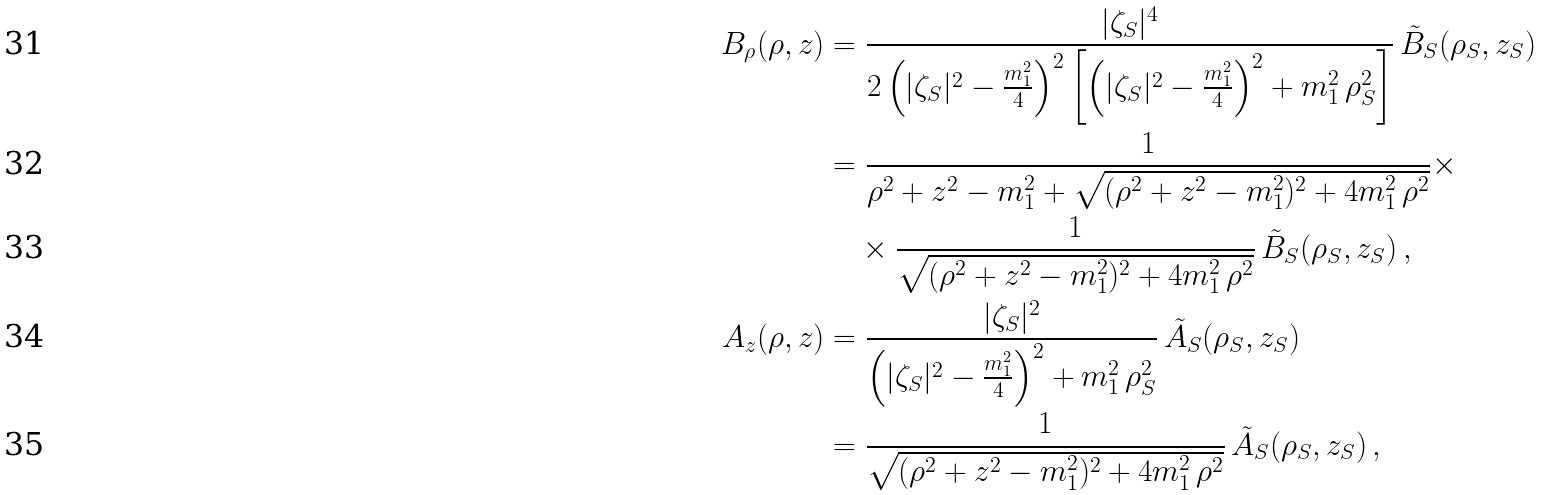<formula> <loc_0><loc_0><loc_500><loc_500>B _ { \rho } ( \rho , z ) & = \frac { | \zeta _ { S } | ^ { 4 } } { 2 \left ( | \zeta _ { S } | ^ { 2 } - \frac { m _ { 1 } ^ { 2 } } { 4 } \right ) ^ { 2 } \left [ \left ( | \zeta _ { S } | ^ { 2 } - \frac { m _ { 1 } ^ { 2 } } { 4 } \right ) ^ { 2 } + m _ { 1 } ^ { 2 } \, \rho _ { S } ^ { 2 } \right ] } \, \tilde { B } _ { S } ( \rho _ { S } , z _ { S } ) \\ & = \frac { 1 } { \rho ^ { 2 } + z ^ { 2 } - m _ { 1 } ^ { 2 } + \sqrt { ( \rho ^ { 2 } + z ^ { 2 } - m _ { 1 } ^ { 2 } ) ^ { 2 } + 4 m _ { 1 } ^ { 2 } \, \rho ^ { 2 } } } \times \\ & \quad \times \frac { 1 } { \sqrt { ( \rho ^ { 2 } + z ^ { 2 } - m _ { 1 } ^ { 2 } ) ^ { 2 } + 4 m _ { 1 } ^ { 2 } \, \rho ^ { 2 } } } \, \tilde { B } _ { S } ( \rho _ { S } , z _ { S } ) \, , \\ A _ { z } ( \rho , z ) & = \frac { | \zeta _ { S } | ^ { 2 } } { \left ( | \zeta _ { S } | ^ { 2 } - \frac { m _ { 1 } ^ { 2 } } { 4 } \right ) ^ { 2 } + m _ { 1 } ^ { 2 } \, \rho _ { S } ^ { 2 } } \, \tilde { A } _ { S } ( \rho _ { S } , z _ { S } ) \\ & = \frac { 1 } { \sqrt { ( \rho ^ { 2 } + z ^ { 2 } - m _ { 1 } ^ { 2 } ) ^ { 2 } + 4 m _ { 1 } ^ { 2 } \, \rho ^ { 2 } } } \, \tilde { A } _ { S } ( \rho _ { S } , z _ { S } ) \, ,</formula> 